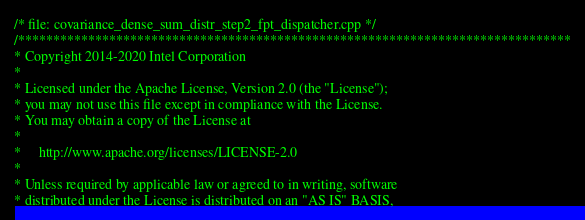<code> <loc_0><loc_0><loc_500><loc_500><_C++_>/* file: covariance_dense_sum_distr_step2_fpt_dispatcher.cpp */
/*******************************************************************************
* Copyright 2014-2020 Intel Corporation
*
* Licensed under the Apache License, Version 2.0 (the "License");
* you may not use this file except in compliance with the License.
* You may obtain a copy of the License at
*
*     http://www.apache.org/licenses/LICENSE-2.0
*
* Unless required by applicable law or agreed to in writing, software
* distributed under the License is distributed on an "AS IS" BASIS,</code> 